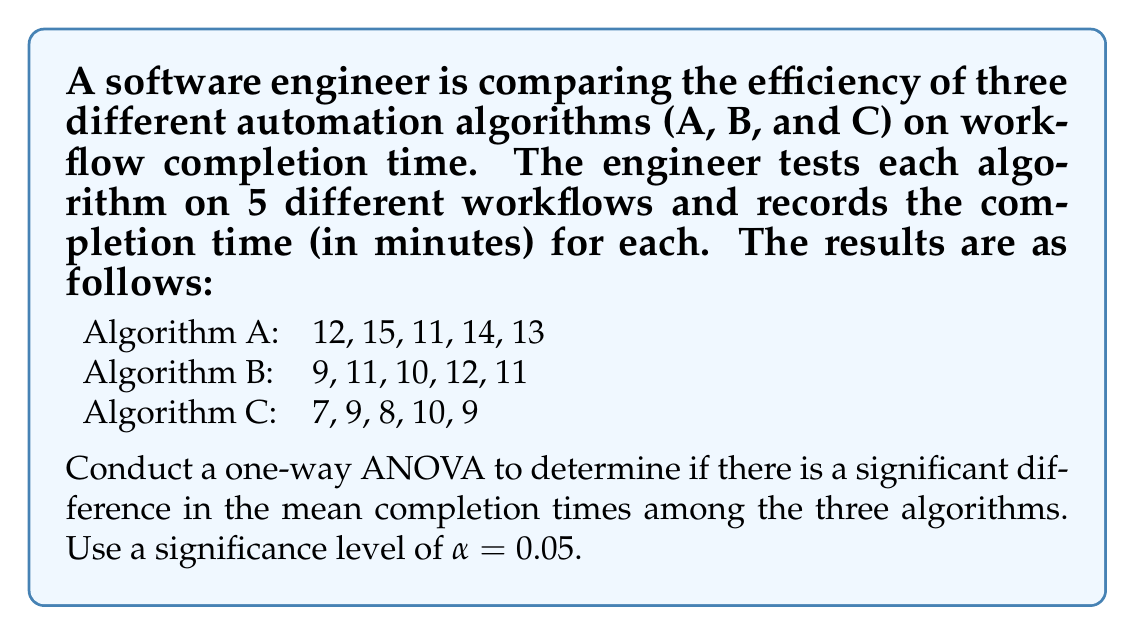Solve this math problem. To conduct a one-way ANOVA, we'll follow these steps:

1. Calculate the sum of squares (SS) for between-groups, within-groups, and total.
2. Calculate the degrees of freedom (df) for between-groups and within-groups.
3. Calculate the mean squares (MS) for between-groups and within-groups.
4. Calculate the F-statistic.
5. Determine the critical F-value and compare it with the calculated F-statistic.

Step 1: Calculate SS

a) Total SS (SST):
Calculate the grand mean: $\bar{X} = \frac{165}{15} = 11$
$$SST = \sum_{i=1}^{k}\sum_{j=1}^{n_i} (X_{ij} - \bar{X})^2 = 122$$

b) Between-groups SS (SSB):
$$SSB = \sum_{i=1}^{k} n_i(\bar{X_i} - \bar{X})^2$$
Where $\bar{X_A} = 13$, $\bar{X_B} = 10.6$, $\bar{X_C} = 8.6$
$$SSB = 5(13-11)^2 + 5(10.6-11)^2 + 5(8.6-11)^2 = 60.4$$

c) Within-groups SS (SSW):
$$SSW = SST - SSB = 122 - 60.4 = 61.6$$

Step 2: Calculate df

Between-groups df: $df_B = k - 1 = 3 - 1 = 2$
Within-groups df: $df_W = N - k = 15 - 3 = 12$

Step 3: Calculate MS

$$MS_B = \frac{SSB}{df_B} = \frac{60.4}{2} = 30.2$$
$$MS_W = \frac{SSW}{df_W} = \frac{61.6}{12} = 5.13$$

Step 4: Calculate F-statistic

$$F = \frac{MS_B}{MS_W} = \frac{30.2}{5.13} = 5.88$$

Step 5: Determine critical F-value and compare

For $\alpha = 0.05$, $df_B = 2$, and $df_W = 12$, the critical F-value is approximately 3.89.

Since the calculated F-statistic (5.88) is greater than the critical F-value (3.89), we reject the null hypothesis.
Answer: The one-way ANOVA results show a significant difference in mean completion times among the three algorithms (F(2,12) = 5.88, p < 0.05). We reject the null hypothesis and conclude that at least one algorithm's mean completion time differs significantly from the others. 